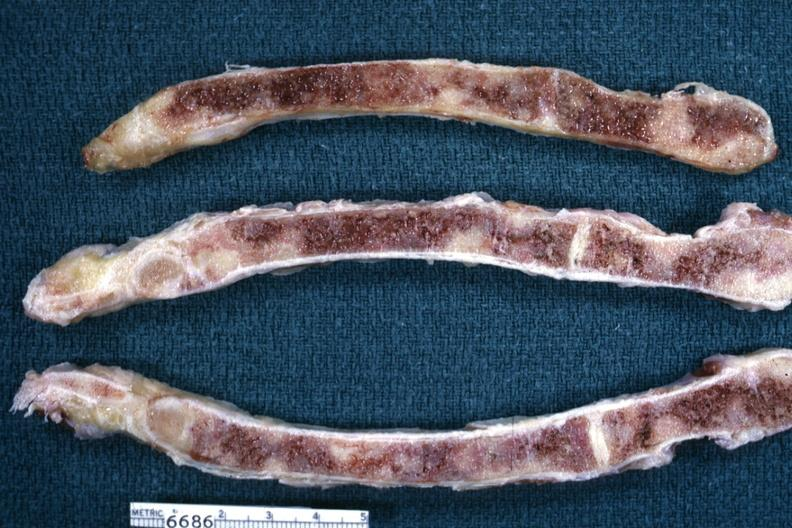how does this image show sections of sternum?
Answer the question using a single word or phrase. With metastatic lesions from breast 